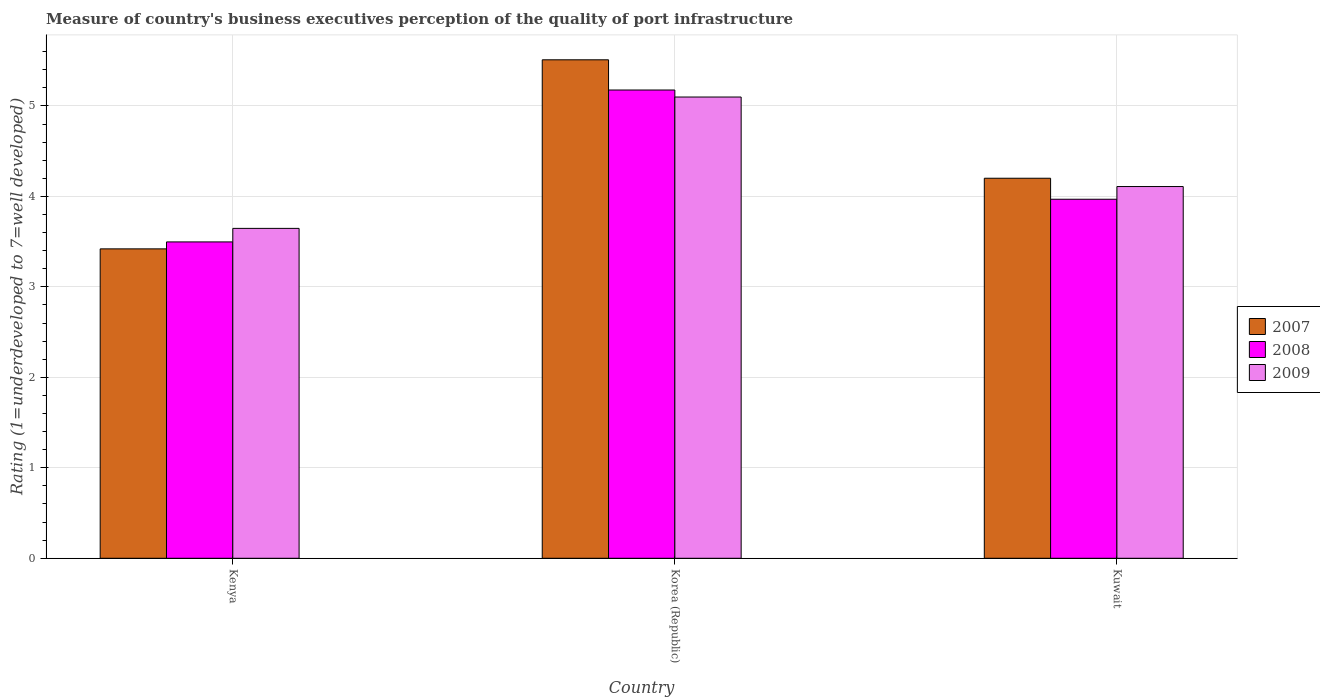How many groups of bars are there?
Offer a very short reply. 3. Are the number of bars on each tick of the X-axis equal?
Give a very brief answer. Yes. How many bars are there on the 2nd tick from the left?
Offer a terse response. 3. How many bars are there on the 2nd tick from the right?
Offer a terse response. 3. What is the label of the 1st group of bars from the left?
Keep it short and to the point. Kenya. In how many cases, is the number of bars for a given country not equal to the number of legend labels?
Your answer should be compact. 0. What is the ratings of the quality of port infrastructure in 2008 in Kenya?
Provide a succinct answer. 3.5. Across all countries, what is the maximum ratings of the quality of port infrastructure in 2009?
Offer a very short reply. 5.1. Across all countries, what is the minimum ratings of the quality of port infrastructure in 2007?
Give a very brief answer. 3.42. In which country was the ratings of the quality of port infrastructure in 2007 maximum?
Make the answer very short. Korea (Republic). In which country was the ratings of the quality of port infrastructure in 2007 minimum?
Your answer should be compact. Kenya. What is the total ratings of the quality of port infrastructure in 2008 in the graph?
Your answer should be compact. 12.64. What is the difference between the ratings of the quality of port infrastructure in 2009 in Kenya and that in Kuwait?
Ensure brevity in your answer.  -0.46. What is the difference between the ratings of the quality of port infrastructure in 2008 in Kuwait and the ratings of the quality of port infrastructure in 2009 in Korea (Republic)?
Your answer should be very brief. -1.13. What is the average ratings of the quality of port infrastructure in 2007 per country?
Your answer should be very brief. 4.38. What is the difference between the ratings of the quality of port infrastructure of/in 2007 and ratings of the quality of port infrastructure of/in 2009 in Kenya?
Offer a very short reply. -0.23. What is the ratio of the ratings of the quality of port infrastructure in 2008 in Korea (Republic) to that in Kuwait?
Give a very brief answer. 1.3. Is the ratings of the quality of port infrastructure in 2008 in Kenya less than that in Kuwait?
Offer a very short reply. Yes. What is the difference between the highest and the second highest ratings of the quality of port infrastructure in 2007?
Offer a terse response. -0.78. What is the difference between the highest and the lowest ratings of the quality of port infrastructure in 2007?
Provide a short and direct response. 2.09. In how many countries, is the ratings of the quality of port infrastructure in 2007 greater than the average ratings of the quality of port infrastructure in 2007 taken over all countries?
Offer a very short reply. 1. Is the sum of the ratings of the quality of port infrastructure in 2007 in Korea (Republic) and Kuwait greater than the maximum ratings of the quality of port infrastructure in 2009 across all countries?
Provide a succinct answer. Yes. What does the 2nd bar from the left in Korea (Republic) represents?
Give a very brief answer. 2008. What does the 1st bar from the right in Kuwait represents?
Your response must be concise. 2009. Is it the case that in every country, the sum of the ratings of the quality of port infrastructure in 2007 and ratings of the quality of port infrastructure in 2008 is greater than the ratings of the quality of port infrastructure in 2009?
Provide a short and direct response. Yes. Are all the bars in the graph horizontal?
Provide a succinct answer. No. How many countries are there in the graph?
Ensure brevity in your answer.  3. What is the difference between two consecutive major ticks on the Y-axis?
Give a very brief answer. 1. Does the graph contain any zero values?
Offer a terse response. No. Where does the legend appear in the graph?
Provide a succinct answer. Center right. How are the legend labels stacked?
Offer a terse response. Vertical. What is the title of the graph?
Provide a succinct answer. Measure of country's business executives perception of the quality of port infrastructure. What is the label or title of the Y-axis?
Provide a succinct answer. Rating (1=underdeveloped to 7=well developed). What is the Rating (1=underdeveloped to 7=well developed) in 2007 in Kenya?
Ensure brevity in your answer.  3.42. What is the Rating (1=underdeveloped to 7=well developed) in 2008 in Kenya?
Give a very brief answer. 3.5. What is the Rating (1=underdeveloped to 7=well developed) of 2009 in Kenya?
Your answer should be very brief. 3.65. What is the Rating (1=underdeveloped to 7=well developed) of 2007 in Korea (Republic)?
Provide a short and direct response. 5.51. What is the Rating (1=underdeveloped to 7=well developed) of 2008 in Korea (Republic)?
Provide a short and direct response. 5.18. What is the Rating (1=underdeveloped to 7=well developed) in 2009 in Korea (Republic)?
Give a very brief answer. 5.1. What is the Rating (1=underdeveloped to 7=well developed) of 2007 in Kuwait?
Your answer should be very brief. 4.2. What is the Rating (1=underdeveloped to 7=well developed) in 2008 in Kuwait?
Ensure brevity in your answer.  3.97. What is the Rating (1=underdeveloped to 7=well developed) in 2009 in Kuwait?
Give a very brief answer. 4.11. Across all countries, what is the maximum Rating (1=underdeveloped to 7=well developed) of 2007?
Provide a succinct answer. 5.51. Across all countries, what is the maximum Rating (1=underdeveloped to 7=well developed) in 2008?
Offer a very short reply. 5.18. Across all countries, what is the maximum Rating (1=underdeveloped to 7=well developed) in 2009?
Offer a very short reply. 5.1. Across all countries, what is the minimum Rating (1=underdeveloped to 7=well developed) of 2007?
Your response must be concise. 3.42. Across all countries, what is the minimum Rating (1=underdeveloped to 7=well developed) of 2008?
Provide a short and direct response. 3.5. Across all countries, what is the minimum Rating (1=underdeveloped to 7=well developed) in 2009?
Your answer should be compact. 3.65. What is the total Rating (1=underdeveloped to 7=well developed) of 2007 in the graph?
Provide a short and direct response. 13.13. What is the total Rating (1=underdeveloped to 7=well developed) in 2008 in the graph?
Give a very brief answer. 12.64. What is the total Rating (1=underdeveloped to 7=well developed) in 2009 in the graph?
Give a very brief answer. 12.85. What is the difference between the Rating (1=underdeveloped to 7=well developed) in 2007 in Kenya and that in Korea (Republic)?
Give a very brief answer. -2.09. What is the difference between the Rating (1=underdeveloped to 7=well developed) in 2008 in Kenya and that in Korea (Republic)?
Ensure brevity in your answer.  -1.68. What is the difference between the Rating (1=underdeveloped to 7=well developed) in 2009 in Kenya and that in Korea (Republic)?
Provide a short and direct response. -1.45. What is the difference between the Rating (1=underdeveloped to 7=well developed) of 2007 in Kenya and that in Kuwait?
Offer a terse response. -0.78. What is the difference between the Rating (1=underdeveloped to 7=well developed) in 2008 in Kenya and that in Kuwait?
Your answer should be compact. -0.47. What is the difference between the Rating (1=underdeveloped to 7=well developed) in 2009 in Kenya and that in Kuwait?
Make the answer very short. -0.46. What is the difference between the Rating (1=underdeveloped to 7=well developed) of 2007 in Korea (Republic) and that in Kuwait?
Offer a very short reply. 1.31. What is the difference between the Rating (1=underdeveloped to 7=well developed) in 2008 in Korea (Republic) and that in Kuwait?
Your response must be concise. 1.21. What is the difference between the Rating (1=underdeveloped to 7=well developed) of 2009 in Korea (Republic) and that in Kuwait?
Your answer should be very brief. 0.99. What is the difference between the Rating (1=underdeveloped to 7=well developed) in 2007 in Kenya and the Rating (1=underdeveloped to 7=well developed) in 2008 in Korea (Republic)?
Make the answer very short. -1.76. What is the difference between the Rating (1=underdeveloped to 7=well developed) of 2007 in Kenya and the Rating (1=underdeveloped to 7=well developed) of 2009 in Korea (Republic)?
Keep it short and to the point. -1.68. What is the difference between the Rating (1=underdeveloped to 7=well developed) in 2008 in Kenya and the Rating (1=underdeveloped to 7=well developed) in 2009 in Korea (Republic)?
Offer a terse response. -1.6. What is the difference between the Rating (1=underdeveloped to 7=well developed) in 2007 in Kenya and the Rating (1=underdeveloped to 7=well developed) in 2008 in Kuwait?
Give a very brief answer. -0.55. What is the difference between the Rating (1=underdeveloped to 7=well developed) of 2007 in Kenya and the Rating (1=underdeveloped to 7=well developed) of 2009 in Kuwait?
Offer a terse response. -0.69. What is the difference between the Rating (1=underdeveloped to 7=well developed) in 2008 in Kenya and the Rating (1=underdeveloped to 7=well developed) in 2009 in Kuwait?
Provide a succinct answer. -0.61. What is the difference between the Rating (1=underdeveloped to 7=well developed) in 2007 in Korea (Republic) and the Rating (1=underdeveloped to 7=well developed) in 2008 in Kuwait?
Provide a succinct answer. 1.54. What is the difference between the Rating (1=underdeveloped to 7=well developed) of 2007 in Korea (Republic) and the Rating (1=underdeveloped to 7=well developed) of 2009 in Kuwait?
Provide a succinct answer. 1.4. What is the difference between the Rating (1=underdeveloped to 7=well developed) in 2008 in Korea (Republic) and the Rating (1=underdeveloped to 7=well developed) in 2009 in Kuwait?
Give a very brief answer. 1.07. What is the average Rating (1=underdeveloped to 7=well developed) in 2007 per country?
Offer a terse response. 4.38. What is the average Rating (1=underdeveloped to 7=well developed) in 2008 per country?
Offer a very short reply. 4.21. What is the average Rating (1=underdeveloped to 7=well developed) in 2009 per country?
Provide a succinct answer. 4.28. What is the difference between the Rating (1=underdeveloped to 7=well developed) of 2007 and Rating (1=underdeveloped to 7=well developed) of 2008 in Kenya?
Your response must be concise. -0.08. What is the difference between the Rating (1=underdeveloped to 7=well developed) in 2007 and Rating (1=underdeveloped to 7=well developed) in 2009 in Kenya?
Make the answer very short. -0.23. What is the difference between the Rating (1=underdeveloped to 7=well developed) of 2008 and Rating (1=underdeveloped to 7=well developed) of 2009 in Kenya?
Make the answer very short. -0.15. What is the difference between the Rating (1=underdeveloped to 7=well developed) of 2007 and Rating (1=underdeveloped to 7=well developed) of 2008 in Korea (Republic)?
Offer a very short reply. 0.33. What is the difference between the Rating (1=underdeveloped to 7=well developed) of 2007 and Rating (1=underdeveloped to 7=well developed) of 2009 in Korea (Republic)?
Keep it short and to the point. 0.41. What is the difference between the Rating (1=underdeveloped to 7=well developed) in 2008 and Rating (1=underdeveloped to 7=well developed) in 2009 in Korea (Republic)?
Your answer should be very brief. 0.08. What is the difference between the Rating (1=underdeveloped to 7=well developed) in 2007 and Rating (1=underdeveloped to 7=well developed) in 2008 in Kuwait?
Provide a short and direct response. 0.23. What is the difference between the Rating (1=underdeveloped to 7=well developed) of 2007 and Rating (1=underdeveloped to 7=well developed) of 2009 in Kuwait?
Provide a short and direct response. 0.09. What is the difference between the Rating (1=underdeveloped to 7=well developed) of 2008 and Rating (1=underdeveloped to 7=well developed) of 2009 in Kuwait?
Offer a very short reply. -0.14. What is the ratio of the Rating (1=underdeveloped to 7=well developed) in 2007 in Kenya to that in Korea (Republic)?
Keep it short and to the point. 0.62. What is the ratio of the Rating (1=underdeveloped to 7=well developed) in 2008 in Kenya to that in Korea (Republic)?
Keep it short and to the point. 0.68. What is the ratio of the Rating (1=underdeveloped to 7=well developed) in 2009 in Kenya to that in Korea (Republic)?
Your answer should be very brief. 0.72. What is the ratio of the Rating (1=underdeveloped to 7=well developed) of 2007 in Kenya to that in Kuwait?
Your answer should be compact. 0.81. What is the ratio of the Rating (1=underdeveloped to 7=well developed) of 2008 in Kenya to that in Kuwait?
Your answer should be compact. 0.88. What is the ratio of the Rating (1=underdeveloped to 7=well developed) of 2009 in Kenya to that in Kuwait?
Provide a succinct answer. 0.89. What is the ratio of the Rating (1=underdeveloped to 7=well developed) in 2007 in Korea (Republic) to that in Kuwait?
Provide a succinct answer. 1.31. What is the ratio of the Rating (1=underdeveloped to 7=well developed) of 2008 in Korea (Republic) to that in Kuwait?
Give a very brief answer. 1.3. What is the ratio of the Rating (1=underdeveloped to 7=well developed) of 2009 in Korea (Republic) to that in Kuwait?
Ensure brevity in your answer.  1.24. What is the difference between the highest and the second highest Rating (1=underdeveloped to 7=well developed) in 2007?
Provide a succinct answer. 1.31. What is the difference between the highest and the second highest Rating (1=underdeveloped to 7=well developed) of 2008?
Offer a terse response. 1.21. What is the difference between the highest and the lowest Rating (1=underdeveloped to 7=well developed) of 2007?
Keep it short and to the point. 2.09. What is the difference between the highest and the lowest Rating (1=underdeveloped to 7=well developed) of 2008?
Your answer should be compact. 1.68. What is the difference between the highest and the lowest Rating (1=underdeveloped to 7=well developed) of 2009?
Make the answer very short. 1.45. 